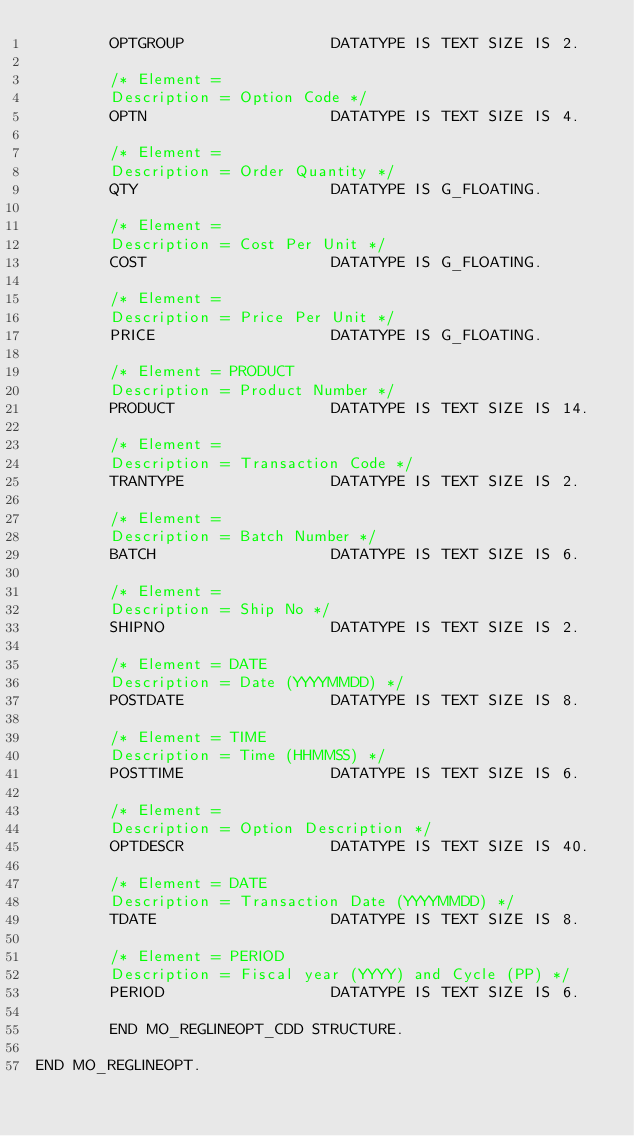<code> <loc_0><loc_0><loc_500><loc_500><_SQL_>        OPTGROUP                DATATYPE IS TEXT SIZE IS 2.

        /* Element =
        Description = Option Code */
        OPTN                    DATATYPE IS TEXT SIZE IS 4.

        /* Element =
        Description = Order Quantity */
        QTY                     DATATYPE IS G_FLOATING.

        /* Element =
        Description = Cost Per Unit */
        COST                    DATATYPE IS G_FLOATING.

        /* Element =
        Description = Price Per Unit */
        PRICE                   DATATYPE IS G_FLOATING.

        /* Element = PRODUCT
        Description = Product Number */
        PRODUCT                 DATATYPE IS TEXT SIZE IS 14.

        /* Element =
        Description = Transaction Code */
        TRANTYPE                DATATYPE IS TEXT SIZE IS 2.

        /* Element =
        Description = Batch Number */
        BATCH                   DATATYPE IS TEXT SIZE IS 6.

        /* Element =
        Description = Ship No */
        SHIPNO                  DATATYPE IS TEXT SIZE IS 2.

        /* Element = DATE
        Description = Date (YYYYMMDD) */
        POSTDATE                DATATYPE IS TEXT SIZE IS 8.

        /* Element = TIME
        Description = Time (HHMMSS) */
        POSTTIME                DATATYPE IS TEXT SIZE IS 6.

        /* Element =
        Description = Option Description */
        OPTDESCR                DATATYPE IS TEXT SIZE IS 40.

        /* Element = DATE
        Description = Transaction Date (YYYYMMDD) */
        TDATE                   DATATYPE IS TEXT SIZE IS 8.

        /* Element = PERIOD
        Description = Fiscal year (YYYY) and Cycle (PP) */
        PERIOD                  DATATYPE IS TEXT SIZE IS 6.

        END MO_REGLINEOPT_CDD STRUCTURE.

END MO_REGLINEOPT.
</code> 